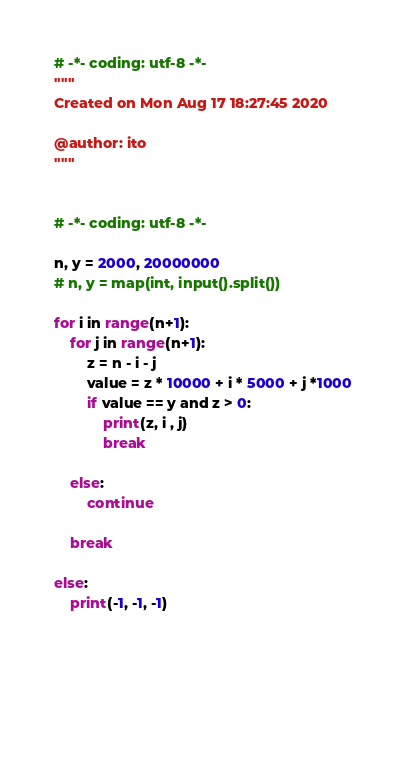<code> <loc_0><loc_0><loc_500><loc_500><_Python_># -*- coding: utf-8 -*-
"""
Created on Mon Aug 17 18:27:45 2020

@author: ito
"""


# -*- coding: utf-8 -*-

n, y = 2000, 20000000
# n, y = map(int, input().split())

for i in range(n+1):
    for j in range(n+1):
        z = n - i - j
        value = z * 10000 + i * 5000 + j *1000
        if value == y and z > 0:
            print(z, i , j)
            break
        
    else:
        continue
    
    break

else:
    print(-1, -1, -1)

            
            
                
                </code> 